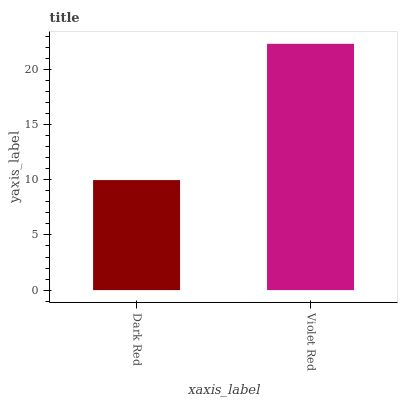Is Violet Red the minimum?
Answer yes or no. No. Is Violet Red greater than Dark Red?
Answer yes or no. Yes. Is Dark Red less than Violet Red?
Answer yes or no. Yes. Is Dark Red greater than Violet Red?
Answer yes or no. No. Is Violet Red less than Dark Red?
Answer yes or no. No. Is Violet Red the high median?
Answer yes or no. Yes. Is Dark Red the low median?
Answer yes or no. Yes. Is Dark Red the high median?
Answer yes or no. No. Is Violet Red the low median?
Answer yes or no. No. 